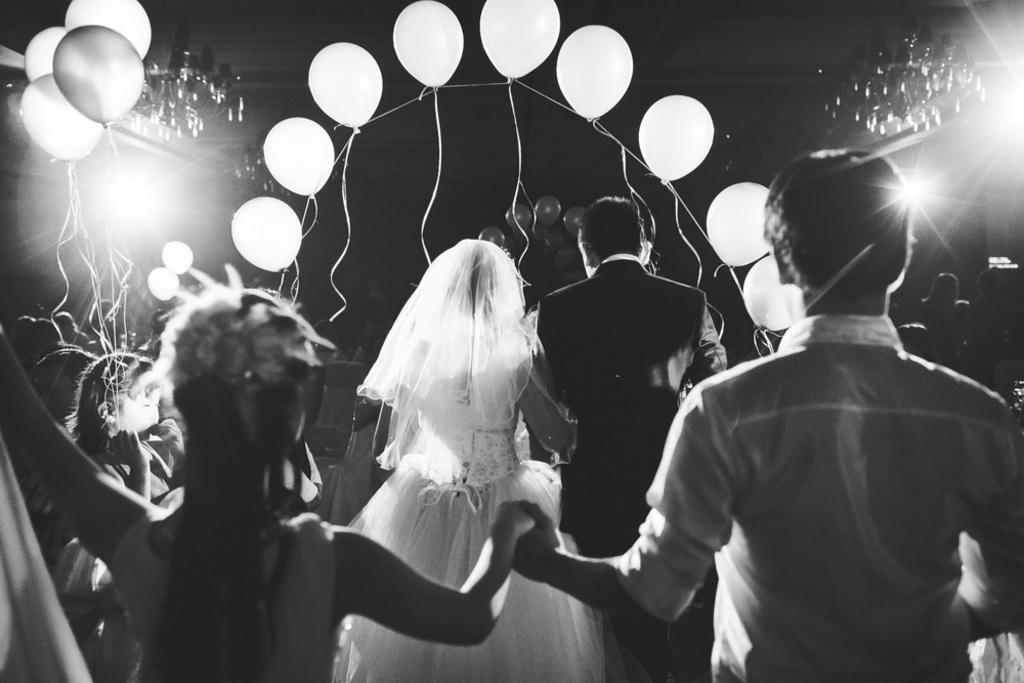Can you describe this image briefly? This is a black and white picture. Here we can see few persons, balloons, and ceiling lights. There is a dark background. 